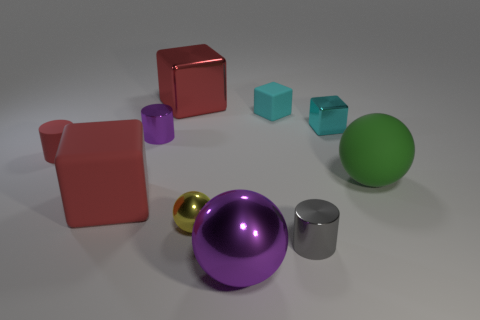Is the big purple object the same shape as the yellow object?
Provide a short and direct response. Yes. How many purple balls are the same material as the tiny purple cylinder?
Provide a succinct answer. 1. What size is the other metal object that is the same shape as the tiny yellow thing?
Provide a succinct answer. Large. Is the size of the red cylinder the same as the cyan matte object?
Ensure brevity in your answer.  Yes. What is the shape of the big red object in front of the rubber object behind the cyan cube in front of the tiny cyan matte block?
Provide a succinct answer. Cube. The other tiny metal thing that is the same shape as the small purple metallic thing is what color?
Offer a very short reply. Gray. What size is the thing that is both in front of the rubber ball and to the left of the red metal cube?
Keep it short and to the point. Large. How many cyan cubes are to the left of the small metal cylinder right of the big red object behind the matte cylinder?
Your answer should be compact. 1. How many tiny things are yellow spheres or matte blocks?
Offer a very short reply. 2. Are the small cylinder right of the tiny yellow shiny thing and the big green thing made of the same material?
Make the answer very short. No. 